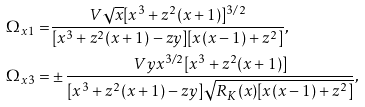Convert formula to latex. <formula><loc_0><loc_0><loc_500><loc_500>\Omega _ { x 1 } = & \frac { V \sqrt { x } [ x ^ { 3 } + z ^ { 2 } ( x + 1 ) ] ^ { 3 / 2 } } { [ x ^ { 3 } + z ^ { 2 } ( x + 1 ) - z y ] [ x ( x - 1 ) + z ^ { 2 } ] } , \\ \Omega _ { x 3 } = & \pm \frac { V y x ^ { 3 / 2 } [ x ^ { 3 } + z ^ { 2 } ( x + 1 ) ] } { [ x ^ { 3 } + z ^ { 2 } ( x + 1 ) - z y ] \sqrt { R _ { K } ( x ) [ x ( x - 1 ) + z ^ { 2 } ] } } ,</formula> 